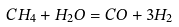Convert formula to latex. <formula><loc_0><loc_0><loc_500><loc_500>C H _ { 4 } + H _ { 2 } O = C O + 3 H _ { 2 }</formula> 